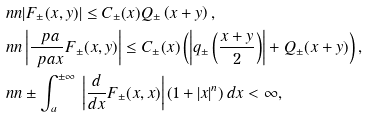<formula> <loc_0><loc_0><loc_500><loc_500>\ n n & | F _ { \pm } ( x , y ) | \leq C _ { \pm } ( x ) Q _ { \pm } \left ( x + y \right ) , \\ \ n n & \left | \frac { \ p a } { \ p a x } F _ { \pm } ( x , y ) \right | \leq C _ { \pm } ( x ) \left ( \left | q _ { \pm } \left ( \frac { x + y } { 2 } \right ) \right | + Q _ { \pm } ( x + y ) \right ) , \\ \ n n & \pm \int _ { a } ^ { \pm \infty } \, \left | \frac { d } { d x } F _ { \pm } ( x , x ) \right | ( 1 + | x | ^ { n } ) \, d x < \infty ,</formula> 